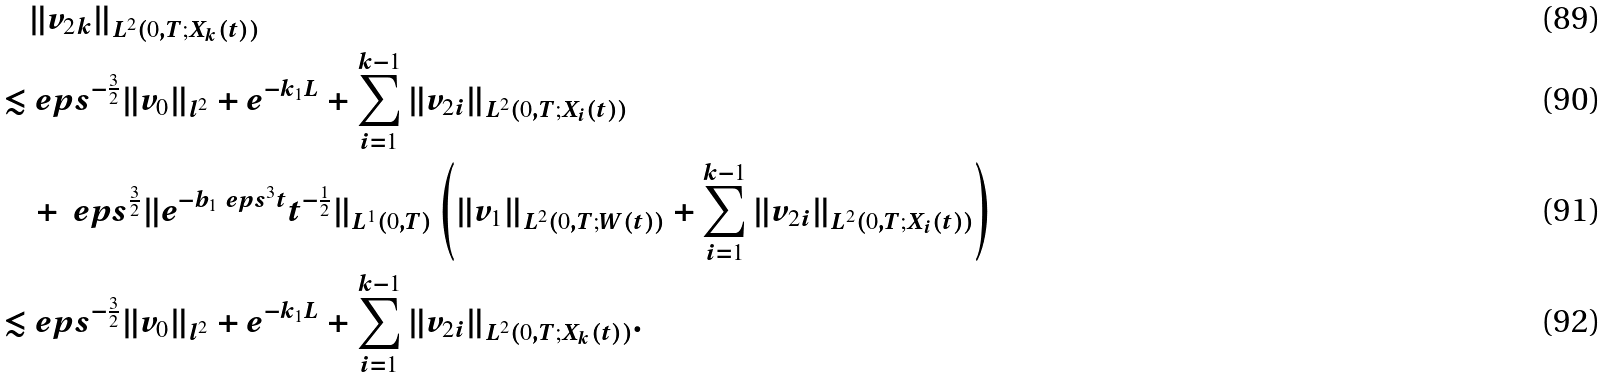<formula> <loc_0><loc_0><loc_500><loc_500>& \| v _ { 2 k } \| _ { L ^ { 2 } ( 0 , T ; X _ { k } ( t ) ) } \\ \lesssim & \ e p s ^ { - \frac { 3 } { 2 } } \| v _ { 0 } \| _ { l ^ { 2 } } + e ^ { - k _ { 1 } L } + \sum _ { i = 1 } ^ { k - 1 } \| v _ { 2 i } \| _ { L ^ { 2 } ( 0 , T ; X _ { i } ( t ) ) } \\ & + \ e p s ^ { \frac { 3 } { 2 } } \| e ^ { - b _ { 1 } \ e p s ^ { 3 } t } t ^ { - \frac { 1 } { 2 } } \| _ { L ^ { 1 } ( 0 , T ) } \left ( \| v _ { 1 } \| _ { L ^ { 2 } ( 0 , T ; W ( t ) ) } + \sum _ { i = 1 } ^ { k - 1 } \| v _ { 2 i } \| _ { L ^ { 2 } ( 0 , T ; X _ { i } ( t ) ) } \right ) \\ \lesssim & \ e p s ^ { - \frac { 3 } { 2 } } \| v _ { 0 } \| _ { l ^ { 2 } } + e ^ { - k _ { 1 } L } + \sum _ { i = 1 } ^ { k - 1 } \| v _ { 2 i } \| _ { L ^ { 2 } ( 0 , T ; X _ { k } ( t ) ) } .</formula> 